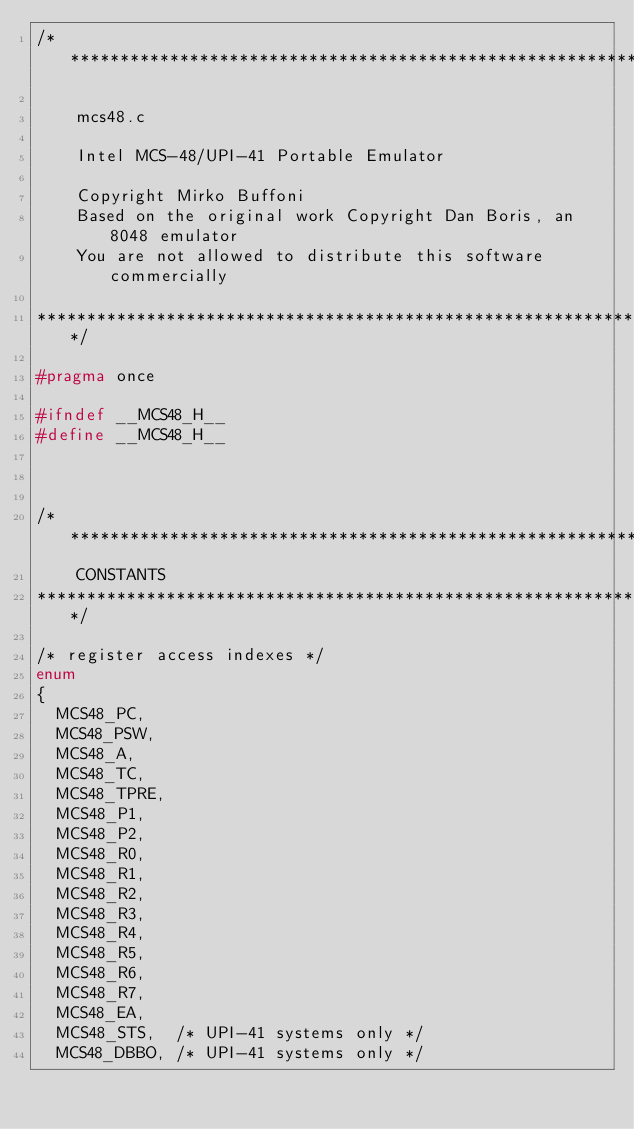Convert code to text. <code><loc_0><loc_0><loc_500><loc_500><_C_>/***************************************************************************

    mcs48.c

    Intel MCS-48/UPI-41 Portable Emulator

    Copyright Mirko Buffoni
    Based on the original work Copyright Dan Boris, an 8048 emulator
    You are not allowed to distribute this software commercially

***************************************************************************/

#pragma once

#ifndef __MCS48_H__
#define __MCS48_H__



/***************************************************************************
    CONSTANTS
***************************************************************************/

/* register access indexes */
enum
{
	MCS48_PC,
	MCS48_PSW,
	MCS48_A,
	MCS48_TC,
	MCS48_TPRE,
	MCS48_P1,
	MCS48_P2,
	MCS48_R0,
	MCS48_R1,
	MCS48_R2,
	MCS48_R3,
	MCS48_R4,
	MCS48_R5,
	MCS48_R6,
	MCS48_R7,
	MCS48_EA,
	MCS48_STS,	/* UPI-41 systems only */
	MCS48_DBBO,	/* UPI-41 systems only */</code> 